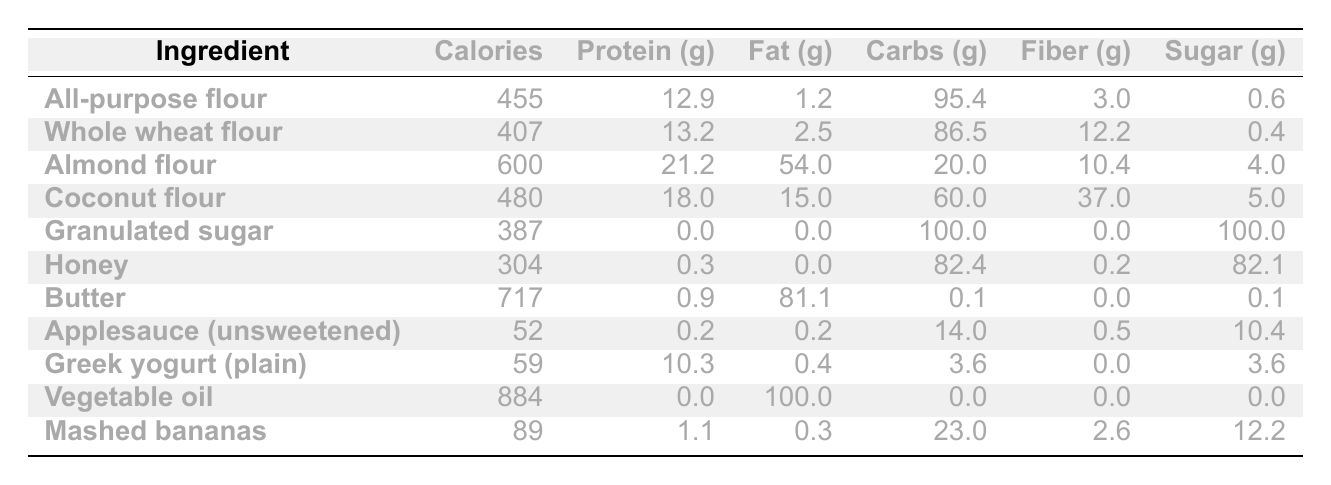What is the calorie content of whole wheat flour? According to the table, whole wheat flour has a calorie content of 407.
Answer: 407 Which ingredient has the highest protein content? Almond flour has the highest protein content at 21.2 grams.
Answer: Almond flour What is the difference in fat content between butter and Greek yogurt? Butter contains 81.1 grams of fat, while Greek yogurt contains 0.4 grams. The difference is 81.1 - 0.4 = 80.7 grams.
Answer: 80.7 grams Is honey a healthier substitute for granulated sugar in terms of calories? Yes, honey has 304 calories compared to granulated sugar's 387 calories, making it lower in calories.
Answer: Yes What are the total carbohydrates in mashed bananas and applesauce combined? Mashed bananas contain 23.0 grams and applesauce has 14.0 grams. Adding these gives 23.0 + 14.0 = 37.0 grams of carbohydrates.
Answer: 37.0 grams Which ingredient has the lowest sugar content? Applesauce has the lowest sugar content, with only 10.4 grams, compared to all other ingredients listed.
Answer: Applesauce What is the average calorie content of all the healthier baking substitutes listed? The healthier substitutes are whole wheat flour, almond flour, coconut flour, honey, applesauce, Greek yogurt, and mashed bananas. Their calorie contents are 407, 600, 480, 304, 52, 59, and 89, respectively. Their total is 407 + 600 + 480 + 304 + 52 + 59 + 89 = 1991. There are 7 ingredients, so the average is 1991 / 7 ≈ 284.43.
Answer: Approximately 284.43 Is there a significant increase in fiber content when using coconut flour compared to all-purpose flour? Yes, coconut flour has 37.0 grams of fiber compared to all-purpose flour's 3.0 grams, which is a significant increase of 34.0 grams.
Answer: Yes What is the total protein content if a recipe includes both almond flour and Greek yogurt? Almond flour contributes 21.2 grams and Greek yogurt contributes 10.3 grams. Adding them gives 21.2 + 10.3 = 31.5 grams of protein.
Answer: 31.5 grams Which ingredient has both the highest fat and the highest calorie content? Vegetable oil has the highest fat content at 100.0 grams and the highest calorie content at 884 calories among all ingredients.
Answer: Vegetable oil 